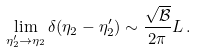<formula> <loc_0><loc_0><loc_500><loc_500>\lim _ { \eta _ { 2 } ^ { \prime } \rightarrow \eta _ { 2 } } \delta ( \eta _ { 2 } - \eta _ { 2 } ^ { \prime } ) \sim \frac { \sqrt { { \mathcal { B } } } } { 2 \pi } L \, .</formula> 